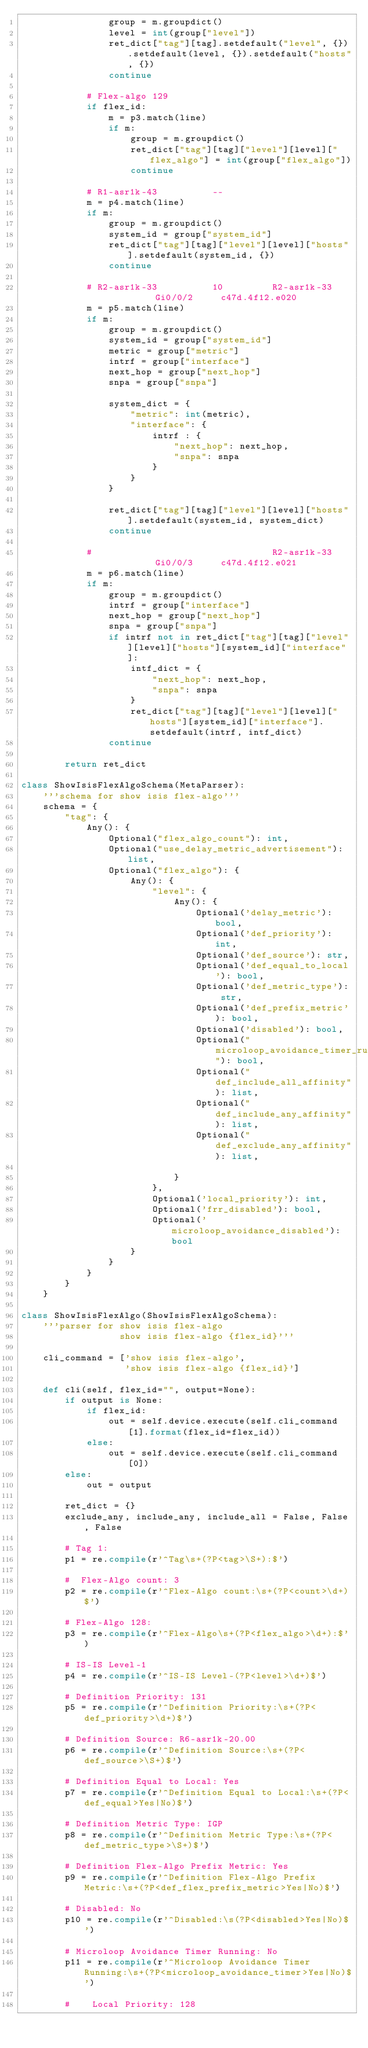<code> <loc_0><loc_0><loc_500><loc_500><_Python_>                group = m.groupdict()
                level = int(group["level"])
                ret_dict["tag"][tag].setdefault("level", {}).setdefault(level, {}).setdefault("hosts", {})
                continue

            # Flex-algo 129
            if flex_id:
                m = p3.match(line)
                if m:
                    group = m.groupdict()
                    ret_dict["tag"][tag]["level"][level]["flex_algo"] = int(group["flex_algo"])
                    continue

            # R1-asr1k-43          --
            m = p4.match(line)
            if m:
                group = m.groupdict()
                system_id = group["system_id"]
                ret_dict["tag"][tag]["level"][level]["hosts"].setdefault(system_id, {})
                continue

            # R2-asr1k-33          10         R2-asr1k-33          Gi0/0/2     c47d.4f12.e020
            m = p5.match(line)
            if m:
                group = m.groupdict()
                system_id = group["system_id"]
                metric = group["metric"]
                intrf = group["interface"]
                next_hop = group["next_hop"]
                snpa = group["snpa"]

                system_dict = {
                    "metric": int(metric),
                    "interface": {
                        intrf : {
                            "next_hop": next_hop,
                            "snpa": snpa
                        }
                    }
                }

                ret_dict["tag"][tag]["level"][level]["hosts"].setdefault(system_id, system_dict)
                continue

            #                                 R2-asr1k-33          Gi0/0/3     c47d.4f12.e021
            m = p6.match(line)
            if m:
                group = m.groupdict()
                intrf = group["interface"]
                next_hop = group["next_hop"]
                snpa = group["snpa"]
                if intrf not in ret_dict["tag"][tag]["level"][level]["hosts"][system_id]["interface"]:
                    intf_dict = {
                        "next_hop": next_hop,
                        "snpa": snpa
                    }
                    ret_dict["tag"][tag]["level"][level]["hosts"][system_id]["interface"].setdefault(intrf, intf_dict)
                continue

        return ret_dict

class ShowIsisFlexAlgoSchema(MetaParser):
    '''schema for show isis flex-algo'''
    schema = {
        "tag": {
            Any(): {
                Optional("flex_algo_count"): int,
                Optional("use_delay_metric_advertisement"): list,
                Optional("flex_algo"): {
                    Any(): {
                        "level": {
                            Any(): {
                                Optional('delay_metric'): bool,
                                Optional('def_priority'): int,
                                Optional('def_source'): str,
                                Optional('def_equal_to_local'): bool,
                                Optional('def_metric_type'): str,
                                Optional('def_prefix_metric'): bool,
                                Optional('disabled'): bool,
                                Optional("microloop_avoidance_timer_running"): bool,
                                Optional("def_include_all_affinity"): list,
                                Optional("def_include_any_affinity"): list,
                                Optional("def_exclude_any_affinity"): list,

                            }
                        },
                        Optional('local_priority'): int,
                        Optional('frr_disabled'): bool,
                        Optional('microloop_avoidance_disabled'): bool
                    }
                }
            }
        }
    }

class ShowIsisFlexAlgo(ShowIsisFlexAlgoSchema):
    '''parser for show isis flex-algo
                  show isis flex-algo {flex_id}'''

    cli_command = ['show isis flex-algo',
                   'show isis flex-algo {flex_id}']

    def cli(self, flex_id="", output=None):
        if output is None:
            if flex_id:
                out = self.device.execute(self.cli_command[1].format(flex_id=flex_id))
            else:
                out = self.device.execute(self.cli_command[0])
        else:
            out = output

        ret_dict = {}
        exclude_any, include_any, include_all = False, False, False

        # Tag 1:
        p1 = re.compile(r'^Tag\s+(?P<tag>\S+):$')

        #  Flex-Algo count: 3
        p2 = re.compile(r'^Flex-Algo count:\s+(?P<count>\d+)$')

        # Flex-Algo 128:
        p3 = re.compile(r'^Flex-Algo\s+(?P<flex_algo>\d+):$')

        # IS-IS Level-1
        p4 = re.compile(r'^IS-IS Level-(?P<level>\d+)$')

        # Definition Priority: 131
        p5 = re.compile(r'^Definition Priority:\s+(?P<def_priority>\d+)$')

        # Definition Source: R6-asr1k-20.00
        p6 = re.compile(r'^Definition Source:\s+(?P<def_source>\S+)$')

        # Definition Equal to Local: Yes
        p7 = re.compile(r'^Definition Equal to Local:\s+(?P<def_equal>Yes|No)$')

        # Definition Metric Type: IGP
        p8 = re.compile(r'^Definition Metric Type:\s+(?P<def_metric_type>\S+)$')

        # Definition Flex-Algo Prefix Metric: Yes
        p9 = re.compile(r'^Definition Flex-Algo Prefix Metric:\s+(?P<def_flex_prefix_metric>Yes|No)$')

        # Disabled: No
        p10 = re.compile(r'^Disabled:\s(?P<disabled>Yes|No)$')

        # Microloop Avoidance Timer Running: No
        p11 = re.compile(r'^Microloop Avoidance Timer Running:\s+(?P<microloop_avoidance_timer>Yes|No)$')

        #    Local Priority: 128</code> 